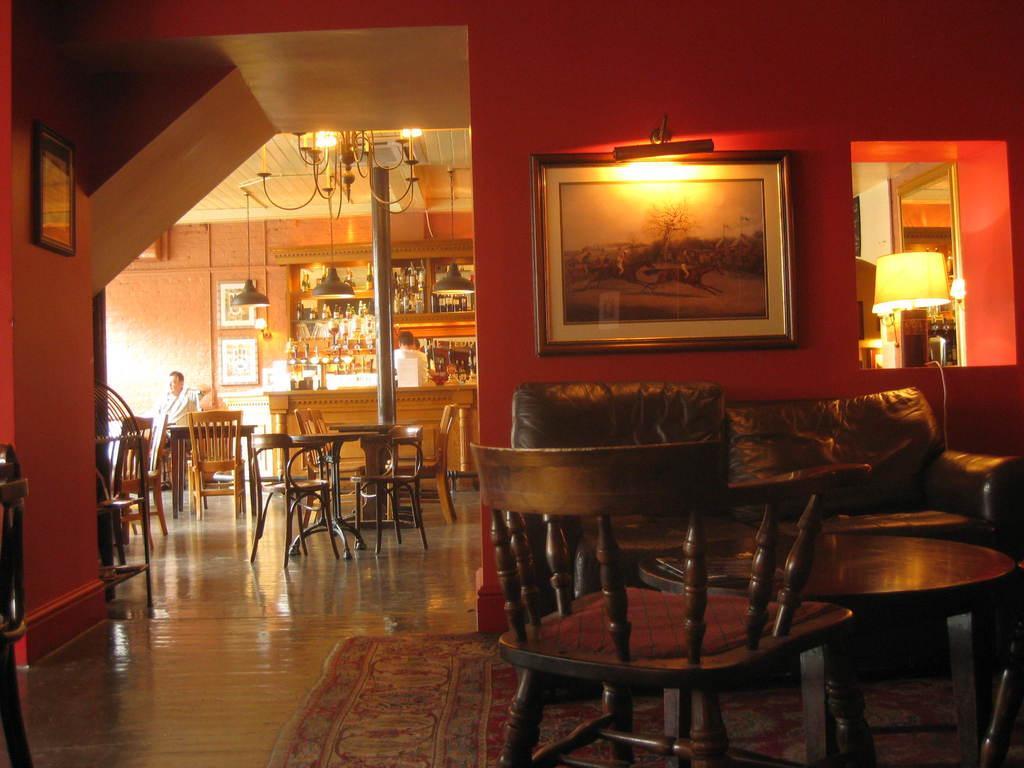How would you summarize this image in a sentence or two? In this image there are chairs and we can see lights. There are people. We can see tables. There are frames placed on the walls. We can see bottles in the rack. At the bottom we can see a carpet. On the right there is a lamp placed on the wall. 